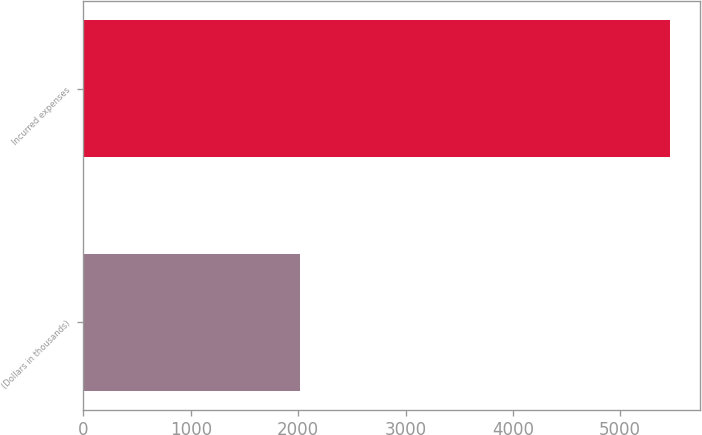Convert chart. <chart><loc_0><loc_0><loc_500><loc_500><bar_chart><fcel>(Dollars in thousands)<fcel>Incurred expenses<nl><fcel>2015<fcel>5468<nl></chart> 